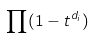<formula> <loc_0><loc_0><loc_500><loc_500>\prod ( 1 - t ^ { d _ { i } } )</formula> 